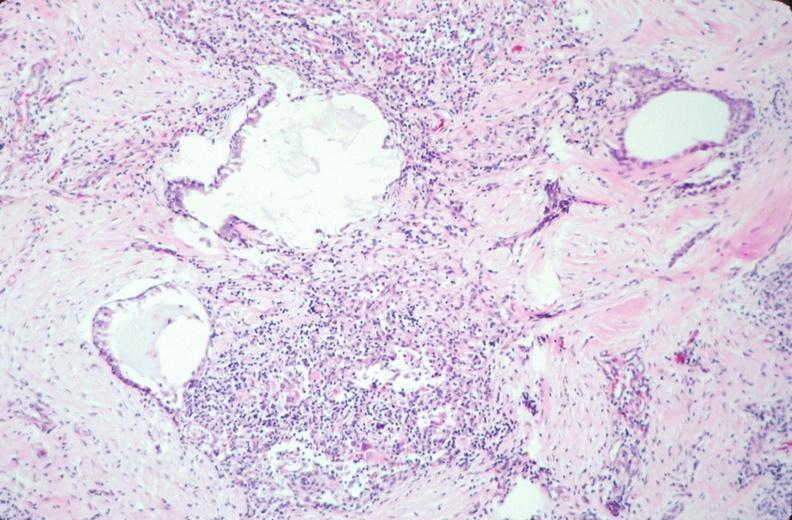what is embryo-fetus?
Answer the question using a single word or phrase. Fetus present 